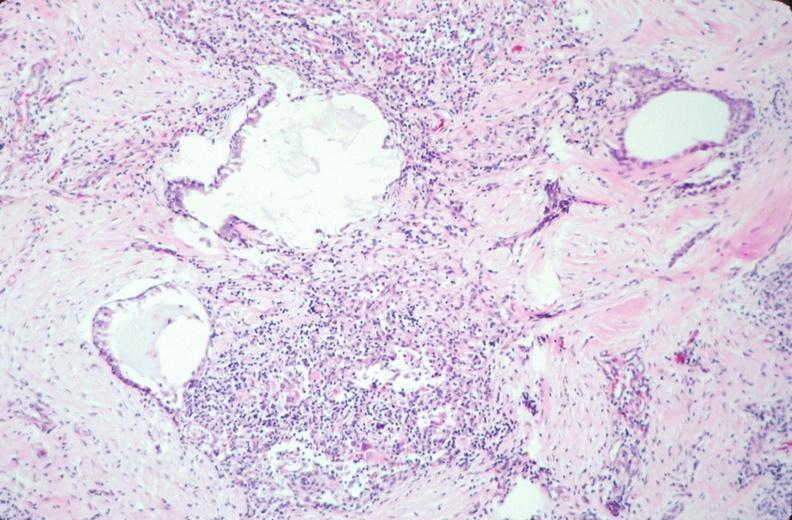what is embryo-fetus?
Answer the question using a single word or phrase. Fetus present 